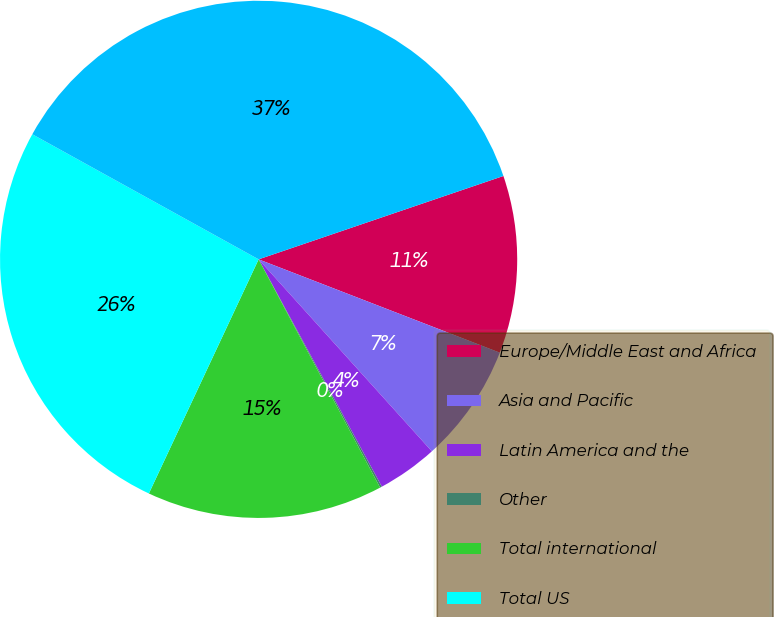Convert chart to OTSL. <chart><loc_0><loc_0><loc_500><loc_500><pie_chart><fcel>Europe/Middle East and Africa<fcel>Asia and Pacific<fcel>Latin America and the<fcel>Other<fcel>Total international<fcel>Total US<fcel>Total<nl><fcel>11.1%<fcel>7.44%<fcel>3.78%<fcel>0.12%<fcel>14.76%<fcel>26.06%<fcel>36.74%<nl></chart> 